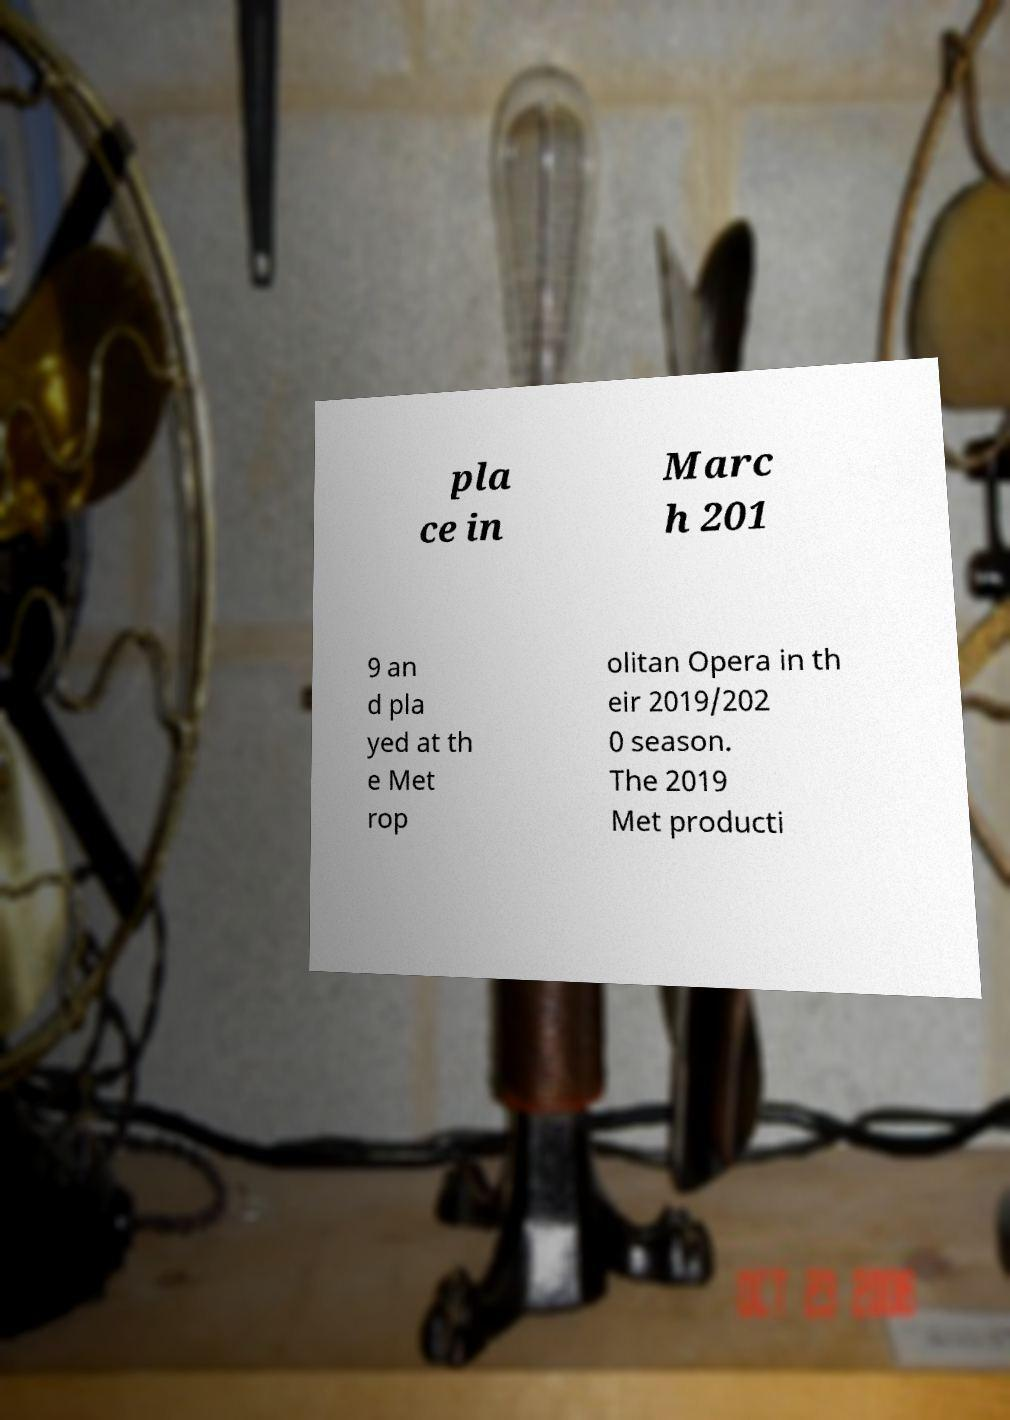I need the written content from this picture converted into text. Can you do that? pla ce in Marc h 201 9 an d pla yed at th e Met rop olitan Opera in th eir 2019/202 0 season. The 2019 Met producti 